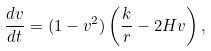Convert formula to latex. <formula><loc_0><loc_0><loc_500><loc_500>\frac { d v } { d t } = ( 1 - v ^ { 2 } ) \left ( \frac { k } { r } - 2 H v \right ) ,</formula> 